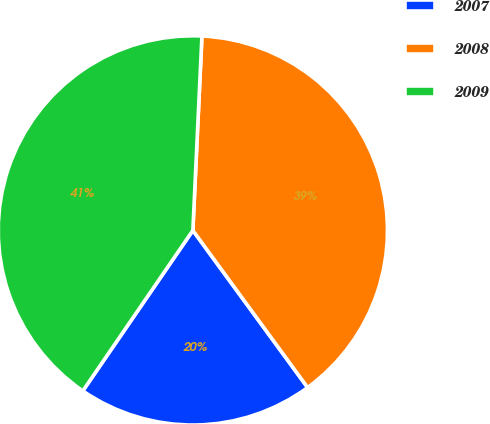<chart> <loc_0><loc_0><loc_500><loc_500><pie_chart><fcel>2007<fcel>2008<fcel>2009<nl><fcel>19.61%<fcel>39.22%<fcel>41.18%<nl></chart> 